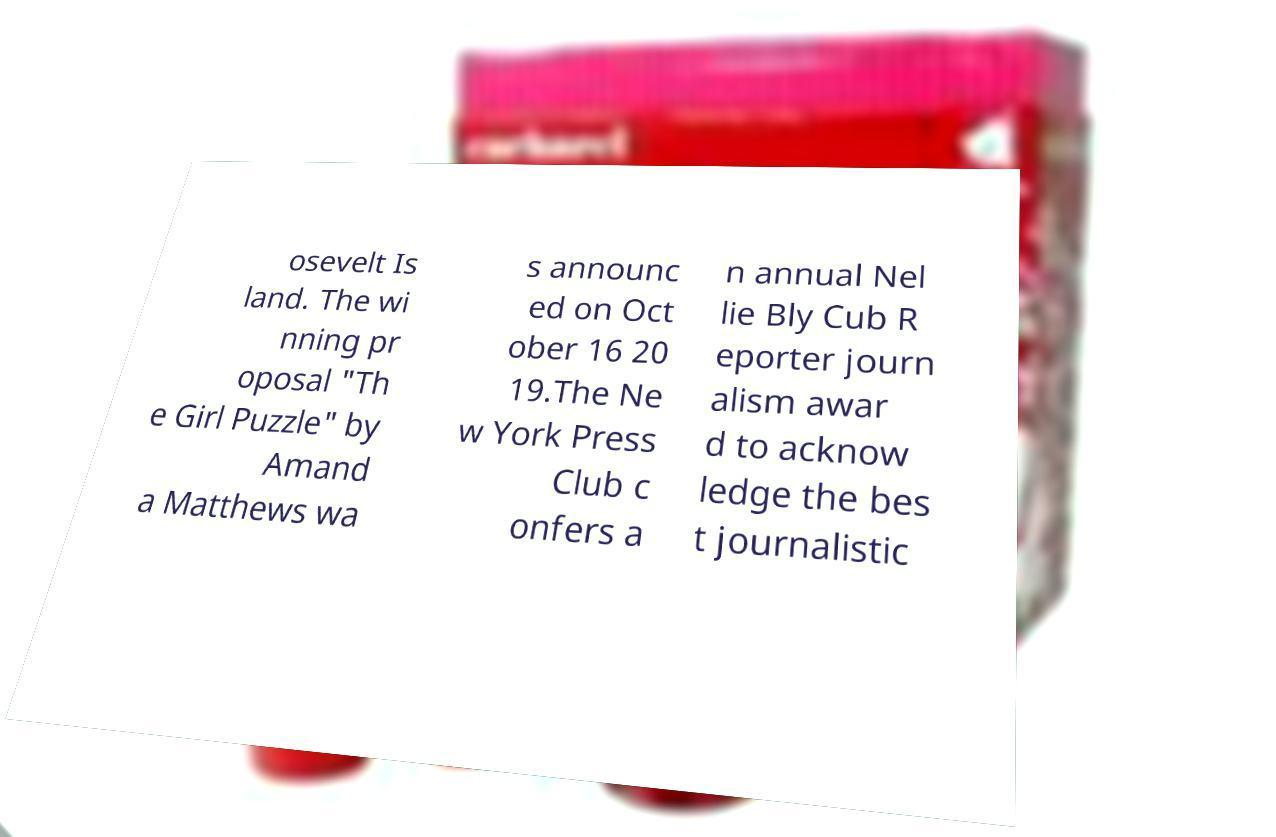There's text embedded in this image that I need extracted. Can you transcribe it verbatim? osevelt Is land. The wi nning pr oposal "Th e Girl Puzzle" by Amand a Matthews wa s announc ed on Oct ober 16 20 19.The Ne w York Press Club c onfers a n annual Nel lie Bly Cub R eporter journ alism awar d to acknow ledge the bes t journalistic 